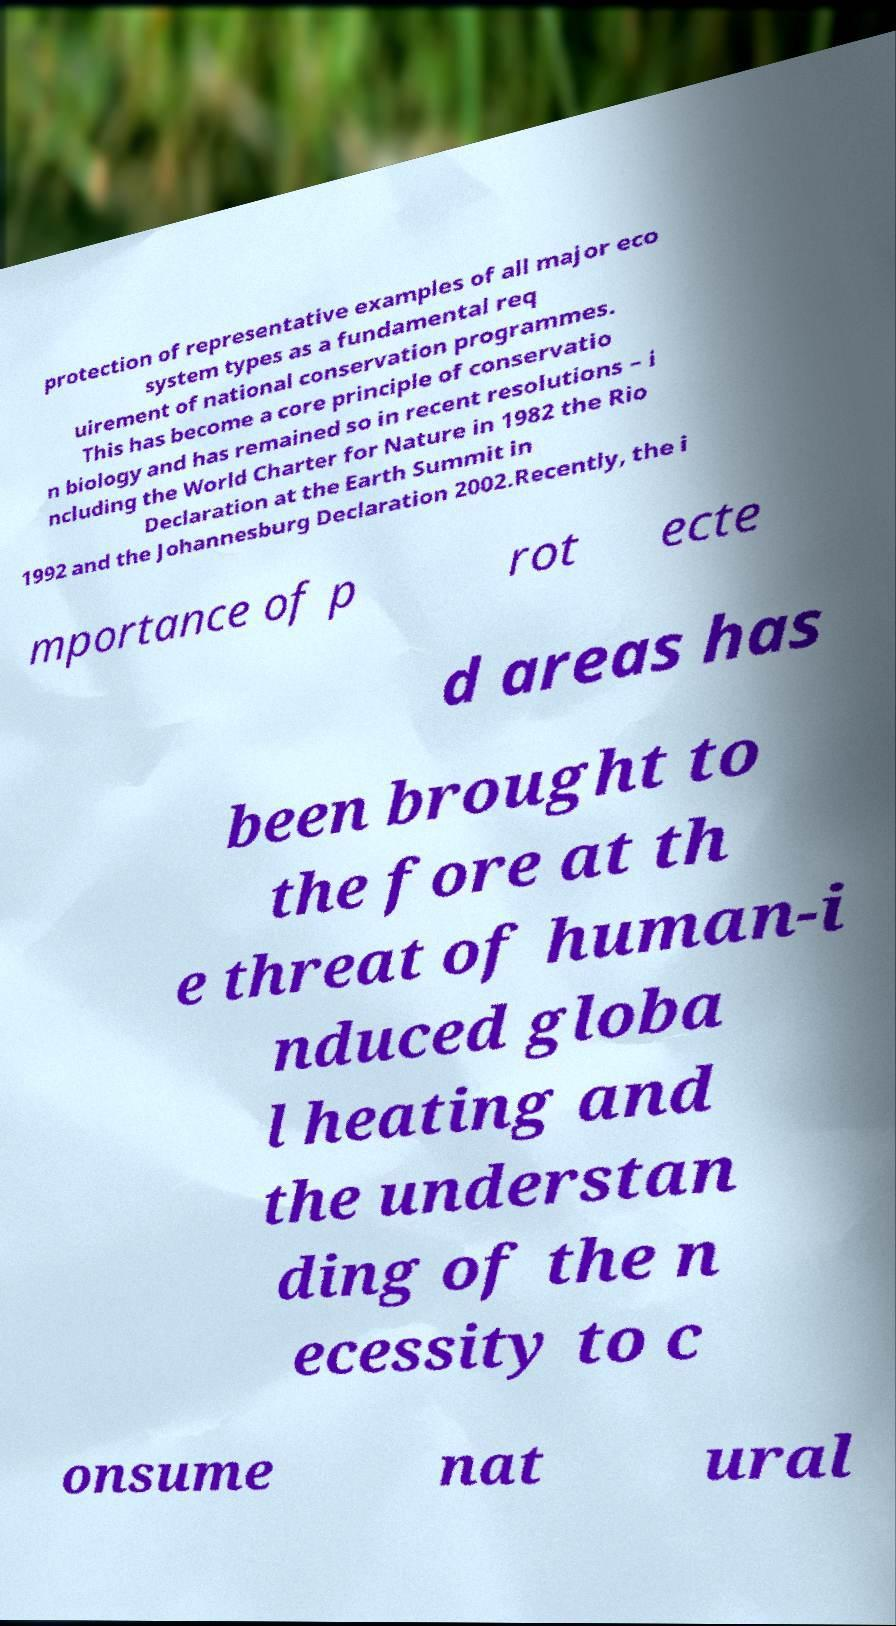For documentation purposes, I need the text within this image transcribed. Could you provide that? protection of representative examples of all major eco system types as a fundamental req uirement of national conservation programmes. This has become a core principle of conservatio n biology and has remained so in recent resolutions – i ncluding the World Charter for Nature in 1982 the Rio Declaration at the Earth Summit in 1992 and the Johannesburg Declaration 2002.Recently, the i mportance of p rot ecte d areas has been brought to the fore at th e threat of human-i nduced globa l heating and the understan ding of the n ecessity to c onsume nat ural 